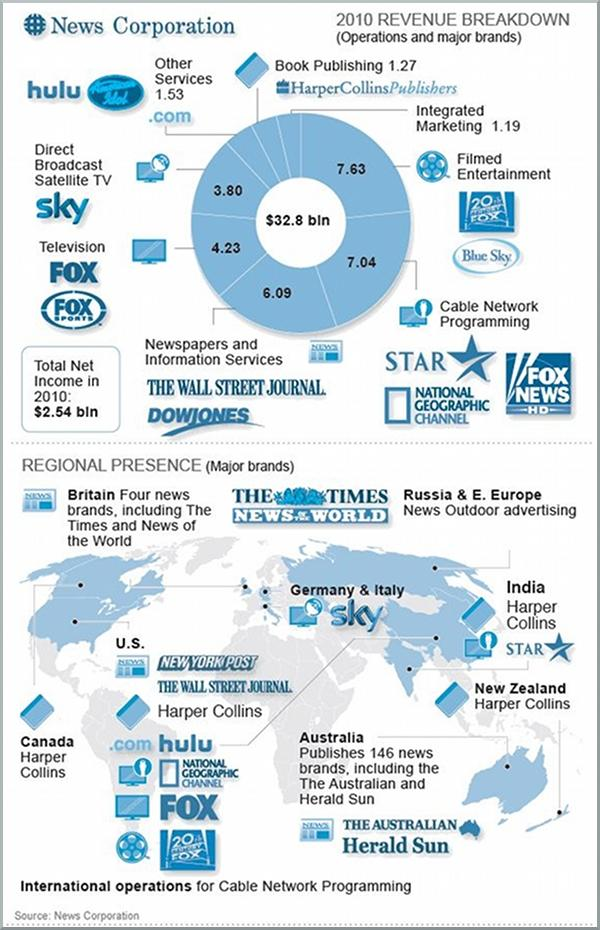Mention a couple of crucial points in this snapshot. In 2010, the highest revenue was generated from the filmed entertainment industry. The total revenue generated from integrated marketing and book publishing was 2.46 billion dollars. Sky is a major brand that is present in Germany and Italy. Harper Collins, aside from being present in Canada, is also present in the United States, New Zealand, and India. Star and HarperCollins are present in India. 